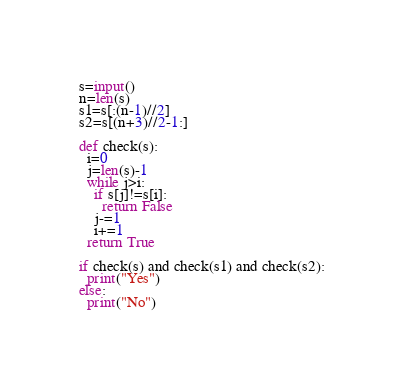<code> <loc_0><loc_0><loc_500><loc_500><_Python_>s=input()
n=len(s)
s1=s[:(n-1)//2]
s2=s[(n+3)//2-1:]

def check(s):
  i=0
  j=len(s)-1
  while j>i:
    if s[j]!=s[i]:
      return False
    j-=1
    i+=1
  return True

if check(s) and check(s1) and check(s2):
  print("Yes")
else:
  print("No")</code> 